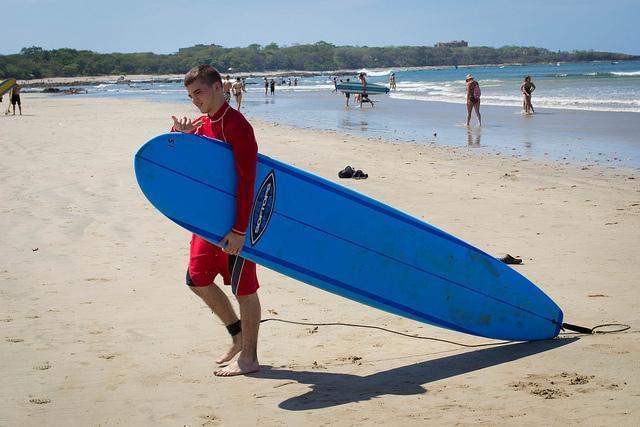How many people are carrying surfboards?
Give a very brief answer. 2. How many people are there?
Give a very brief answer. 1. 